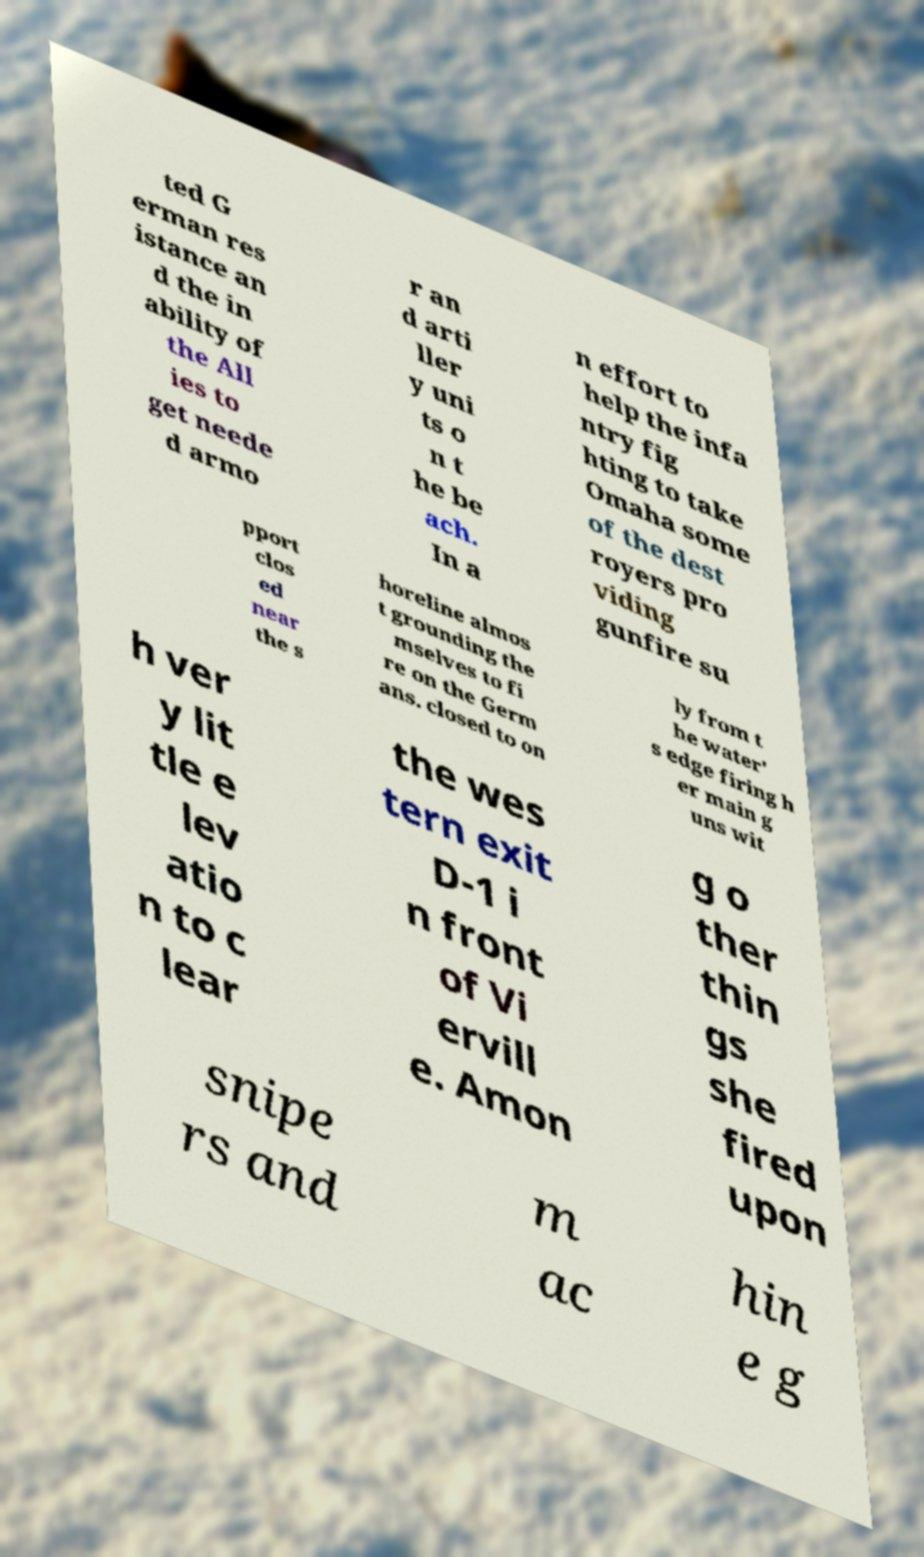There's text embedded in this image that I need extracted. Can you transcribe it verbatim? ted G erman res istance an d the in ability of the All ies to get neede d armo r an d arti ller y uni ts o n t he be ach. In a n effort to help the infa ntry fig hting to take Omaha some of the dest royers pro viding gunfire su pport clos ed near the s horeline almos t grounding the mselves to fi re on the Germ ans. closed to on ly from t he water' s edge firing h er main g uns wit h ver y lit tle e lev atio n to c lear the wes tern exit D-1 i n front of Vi ervill e. Amon g o ther thin gs she fired upon snipe rs and m ac hin e g 